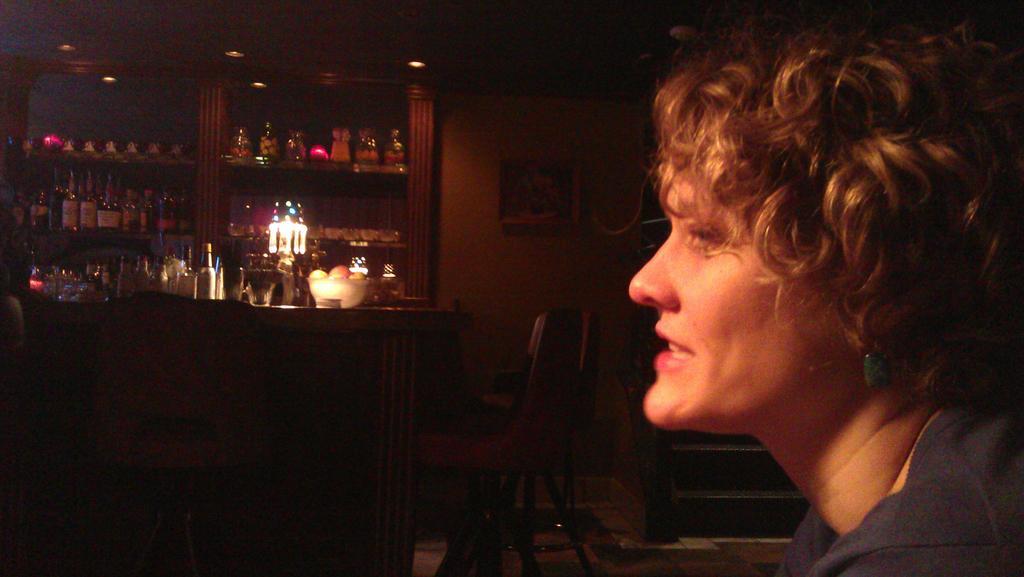How would you summarize this image in a sentence or two? In this picture we can see a woman, steps, chairs, bowl with fruits in it and some objects in racks, lights and a frame on the wall. 